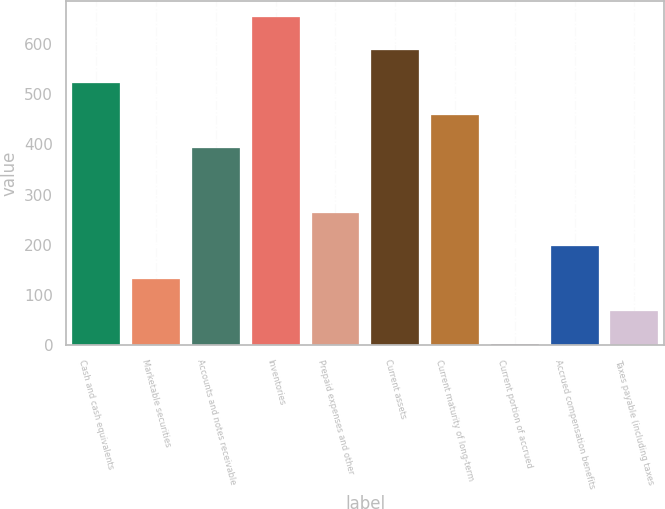Convert chart to OTSL. <chart><loc_0><loc_0><loc_500><loc_500><bar_chart><fcel>Cash and cash equivalents<fcel>Marketable securities<fcel>Accounts and notes receivable<fcel>Inventories<fcel>Prepaid expenses and other<fcel>Current assets<fcel>Current maturity of long-term<fcel>Current portion of accrued<fcel>Accrued compensation benefits<fcel>Taxes payable (including taxes<nl><fcel>523<fcel>133<fcel>393<fcel>653<fcel>263<fcel>588<fcel>458<fcel>3<fcel>198<fcel>68<nl></chart> 